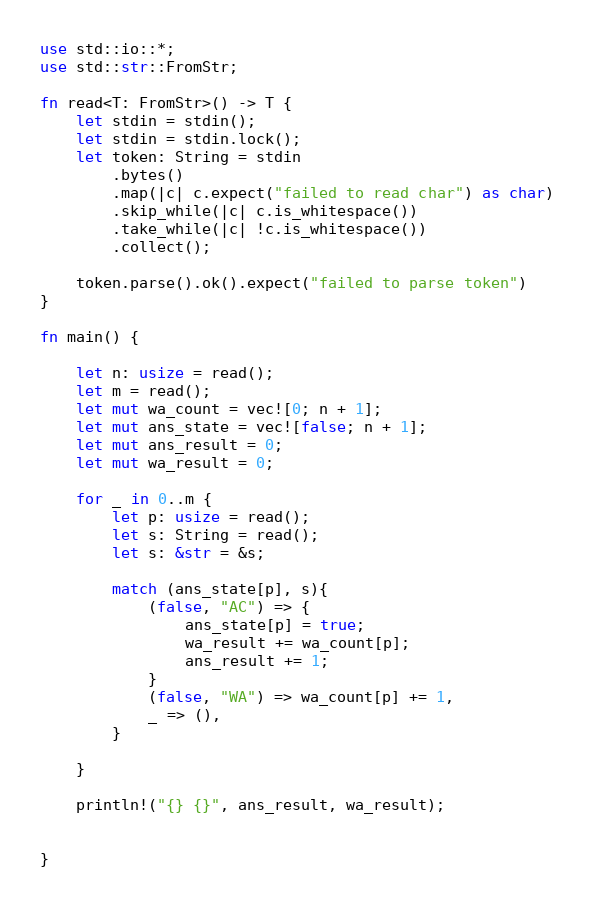<code> <loc_0><loc_0><loc_500><loc_500><_Rust_>use std::io::*;
use std::str::FromStr;

fn read<T: FromStr>() -> T {
    let stdin = stdin();
    let stdin = stdin.lock();
    let token: String = stdin
        .bytes()
        .map(|c| c.expect("failed to read char") as char)
        .skip_while(|c| c.is_whitespace())
        .take_while(|c| !c.is_whitespace())
        .collect();

    token.parse().ok().expect("failed to parse token")
}

fn main() {

    let n: usize = read();
    let m = read();
    let mut wa_count = vec![0; n + 1];
    let mut ans_state = vec![false; n + 1];
    let mut ans_result = 0;
    let mut wa_result = 0;

    for _ in 0..m {
        let p: usize = read();
        let s: String = read();
        let s: &str = &s;

        match (ans_state[p], s){
            (false, "AC") => {
                ans_state[p] = true;
                wa_result += wa_count[p];
                ans_result += 1;    
            }
            (false, "WA") => wa_count[p] += 1,
            _ => (),
        }

    }

    println!("{} {}", ans_result, wa_result);


}
</code> 